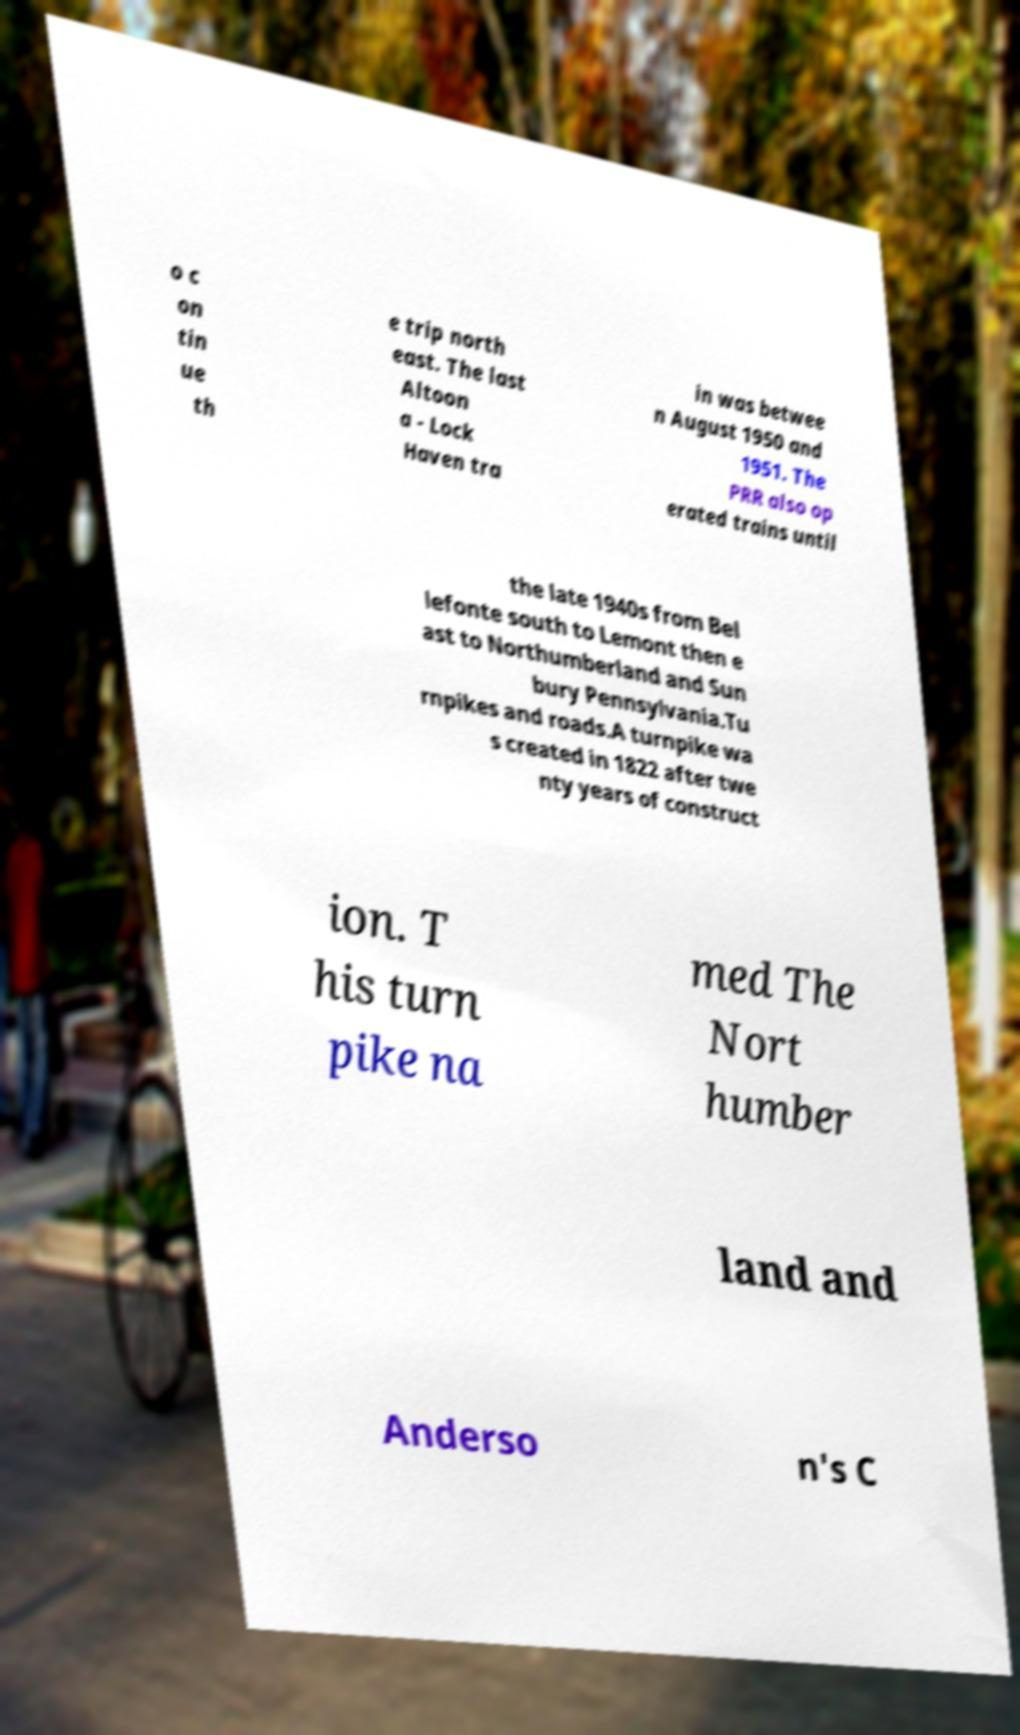There's text embedded in this image that I need extracted. Can you transcribe it verbatim? o c on tin ue th e trip north east. The last Altoon a - Lock Haven tra in was betwee n August 1950 and 1951. The PRR also op erated trains until the late 1940s from Bel lefonte south to Lemont then e ast to Northumberland and Sun bury Pennsylvania.Tu rnpikes and roads.A turnpike wa s created in 1822 after twe nty years of construct ion. T his turn pike na med The Nort humber land and Anderso n's C 